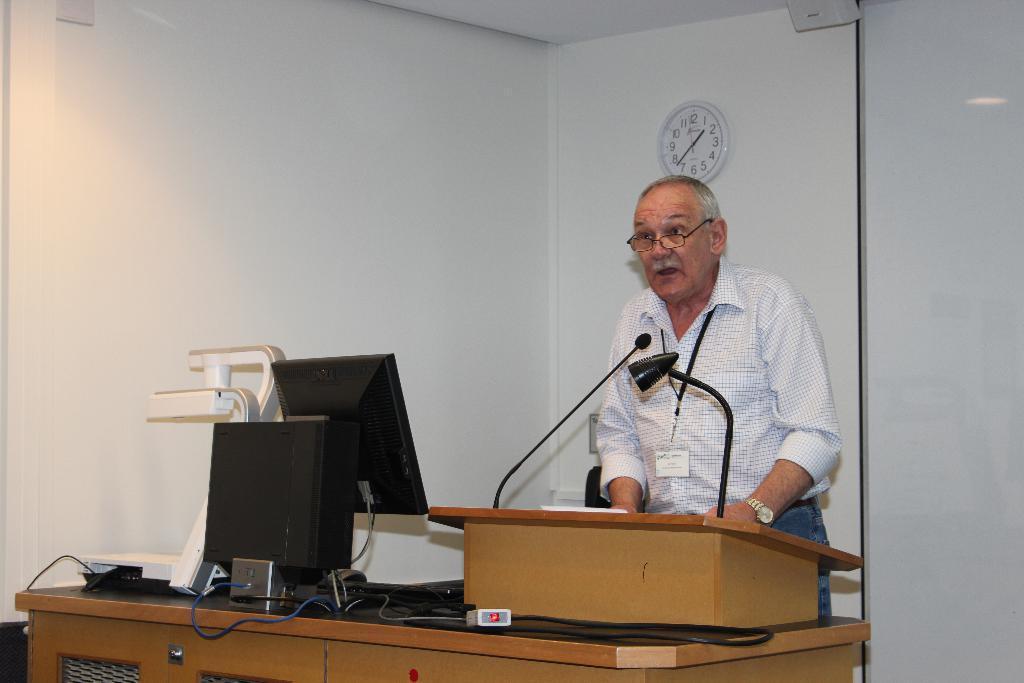Describe this image in one or two sentences. In this picture there is a person who is standing in front of the desk on which there is a system and a mic. 